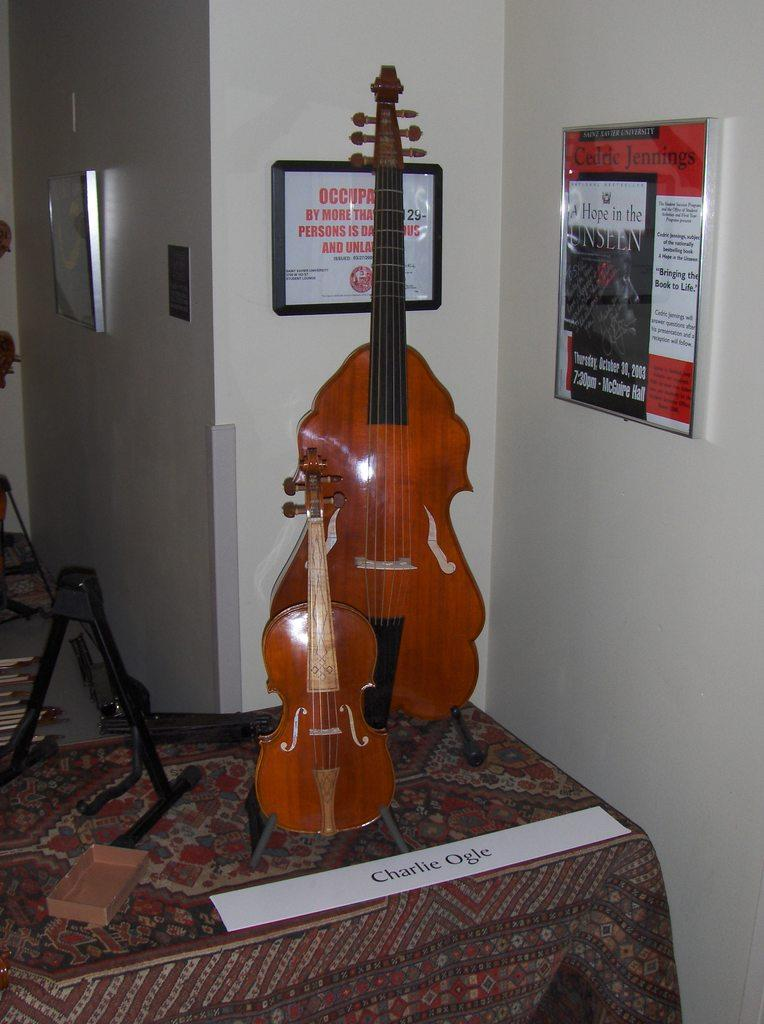What object in the image is used for creating music? There is a musical instrument in the image. Where is the musical instrument located? The musical instrument is on a table. What can be seen attached to the wall in the image? There is a frame attached to the wall in the image. What type of net is being used to catch the snake in the image? There is no net or snake present in the image. 